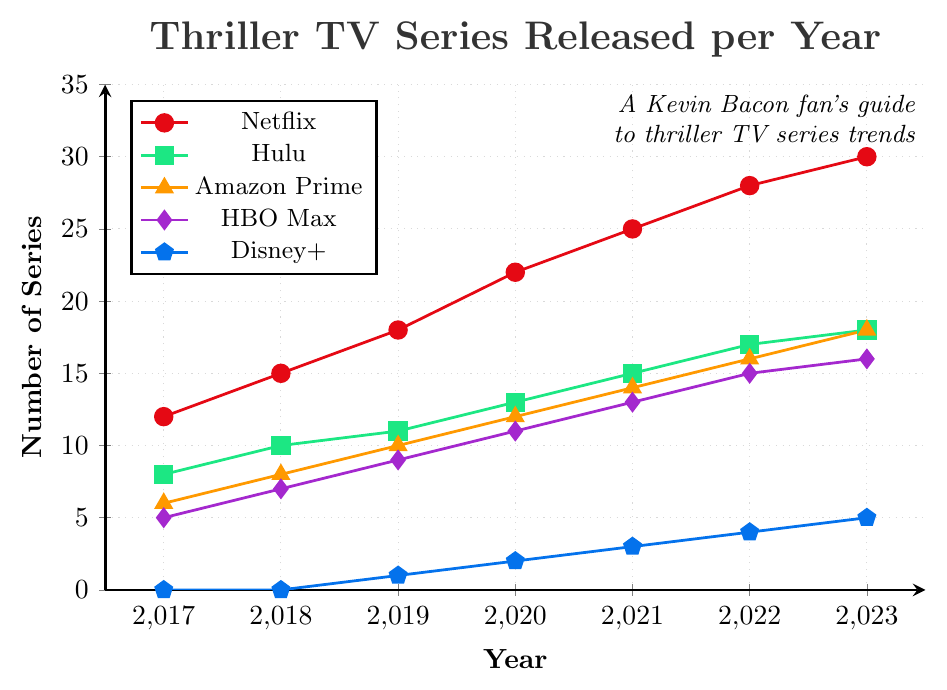what year did Netflix release the most thriller TV series? From the plot, Netflix has the highest number of thriller TV series released in 2023.
Answer: 2023 In what year did Hulu release the least number of thriller TV series? By looking at the Hulu line (green squares), the lowest point is in 2017.
Answer: 2017 Which streaming platform showed the greatest increase in the number of thriller TV series from 2017 to 2023? Comparing the starting and ending points for all lines: Netflix increased from 12 to 30 (18 series), Hulu from 8 to 18 (10 series), Amazon Prime from 6 to 18 (12 series), HBO Max from 5 to 16 (11 series), and Disney+ from 0 to 5 (5 series), Netflix shows the largest increase.
Answer: Netflix By how many series did Amazon Prime surpass HBO Max in 2023? In 2023, Amazon Prime released 18 series and HBO Max released 16 series. The difference is 18 - 16 = 2.
Answer: 2 Which streaming platform had no thriller TV series releases from 2017 to 2018? The blue pentagon markers for Disney+ are at 0 for both 2017 and 2018.
Answer: Disney+ Compare the number of thriller series released by Netflix in 2020 to those by Hulu in the same year. Which was higher and by how much? Netflix released 22 series, and Hulu released 13 in 2020. 22 - 13 = 9, so Netflix released 9 more series than Hulu.
Answer: Netflix by 9 What is the average number of thriller TV series released by HBO Max across all the years shown in the figure? Sum of HBO Max values: 5 + 7 + 9 + 11 + 13 + 15 + 16 = 76. There are 7 years, so the average is 76 / 7 ≈ 10.86.
Answer: 10.86 How many thriller TV series were released by all platforms combined in 2021? Sum the released series for all platforms in 2021: 25 (Netflix) + 15 (Hulu) + 14 (Amazon Prime) + 13 (HBO Max) + 3 (Disney+) = 70.
Answer: 70 Which year did Disney+ start releasing thriller TV series and how many were released that year? The first non-zero value for Disney+ (blue pentagon) is in 2019, with 1 series.
Answer: 2019, 1 series What is the total number of thriller TV series released by Netflix in the first three years shown (2017-2019)? Sum of Netflix releases from 2017 to 2019: 12 + 15 + 18 = 45.
Answer: 45 